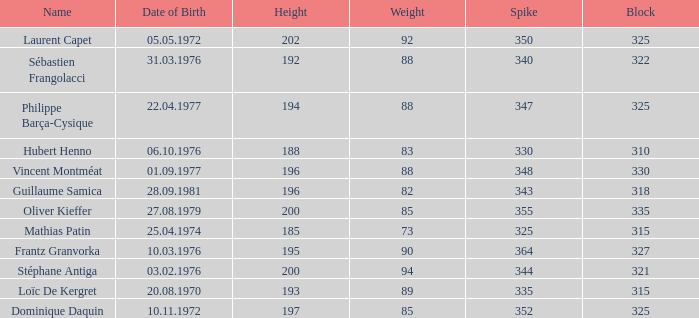How many spikes possess 2 None. 